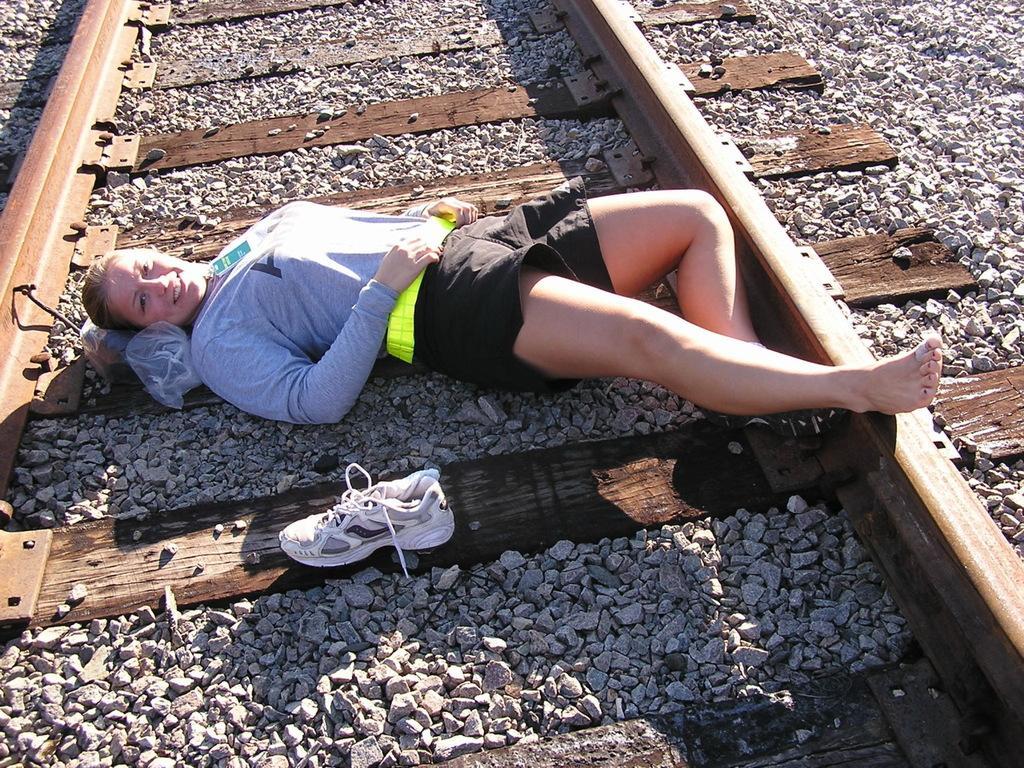Can you describe this image briefly? In this image we can see a woman sleeping on the track. There is a shoe beside her. We can also see some stones. 